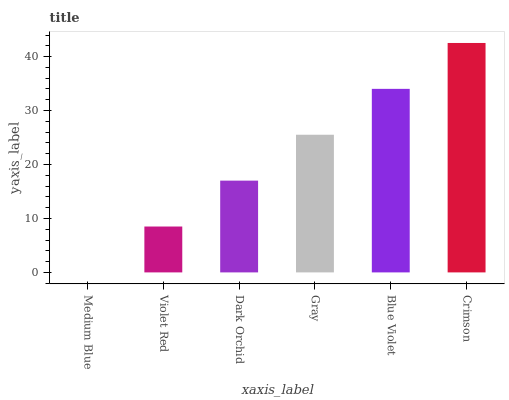Is Medium Blue the minimum?
Answer yes or no. Yes. Is Crimson the maximum?
Answer yes or no. Yes. Is Violet Red the minimum?
Answer yes or no. No. Is Violet Red the maximum?
Answer yes or no. No. Is Violet Red greater than Medium Blue?
Answer yes or no. Yes. Is Medium Blue less than Violet Red?
Answer yes or no. Yes. Is Medium Blue greater than Violet Red?
Answer yes or no. No. Is Violet Red less than Medium Blue?
Answer yes or no. No. Is Gray the high median?
Answer yes or no. Yes. Is Dark Orchid the low median?
Answer yes or no. Yes. Is Medium Blue the high median?
Answer yes or no. No. Is Gray the low median?
Answer yes or no. No. 